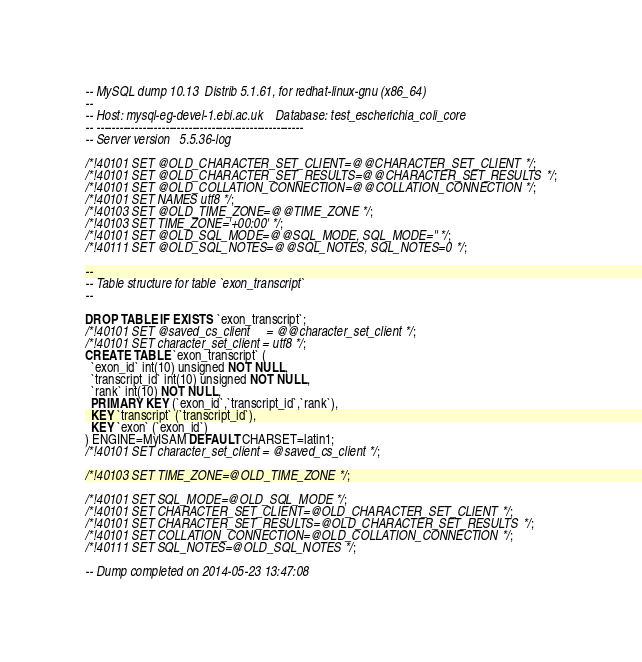Convert code to text. <code><loc_0><loc_0><loc_500><loc_500><_SQL_>-- MySQL dump 10.13  Distrib 5.1.61, for redhat-linux-gnu (x86_64)
--
-- Host: mysql-eg-devel-1.ebi.ac.uk    Database: test_escherichia_coli_core
-- ------------------------------------------------------
-- Server version	5.5.36-log

/*!40101 SET @OLD_CHARACTER_SET_CLIENT=@@CHARACTER_SET_CLIENT */;
/*!40101 SET @OLD_CHARACTER_SET_RESULTS=@@CHARACTER_SET_RESULTS */;
/*!40101 SET @OLD_COLLATION_CONNECTION=@@COLLATION_CONNECTION */;
/*!40101 SET NAMES utf8 */;
/*!40103 SET @OLD_TIME_ZONE=@@TIME_ZONE */;
/*!40103 SET TIME_ZONE='+00:00' */;
/*!40101 SET @OLD_SQL_MODE=@@SQL_MODE, SQL_MODE='' */;
/*!40111 SET @OLD_SQL_NOTES=@@SQL_NOTES, SQL_NOTES=0 */;

--
-- Table structure for table `exon_transcript`
--

DROP TABLE IF EXISTS `exon_transcript`;
/*!40101 SET @saved_cs_client     = @@character_set_client */;
/*!40101 SET character_set_client = utf8 */;
CREATE TABLE `exon_transcript` (
  `exon_id` int(10) unsigned NOT NULL,
  `transcript_id` int(10) unsigned NOT NULL,
  `rank` int(10) NOT NULL,
  PRIMARY KEY (`exon_id`,`transcript_id`,`rank`),
  KEY `transcript` (`transcript_id`),
  KEY `exon` (`exon_id`)
) ENGINE=MyISAM DEFAULT CHARSET=latin1;
/*!40101 SET character_set_client = @saved_cs_client */;

/*!40103 SET TIME_ZONE=@OLD_TIME_ZONE */;

/*!40101 SET SQL_MODE=@OLD_SQL_MODE */;
/*!40101 SET CHARACTER_SET_CLIENT=@OLD_CHARACTER_SET_CLIENT */;
/*!40101 SET CHARACTER_SET_RESULTS=@OLD_CHARACTER_SET_RESULTS */;
/*!40101 SET COLLATION_CONNECTION=@OLD_COLLATION_CONNECTION */;
/*!40111 SET SQL_NOTES=@OLD_SQL_NOTES */;

-- Dump completed on 2014-05-23 13:47:08
</code> 